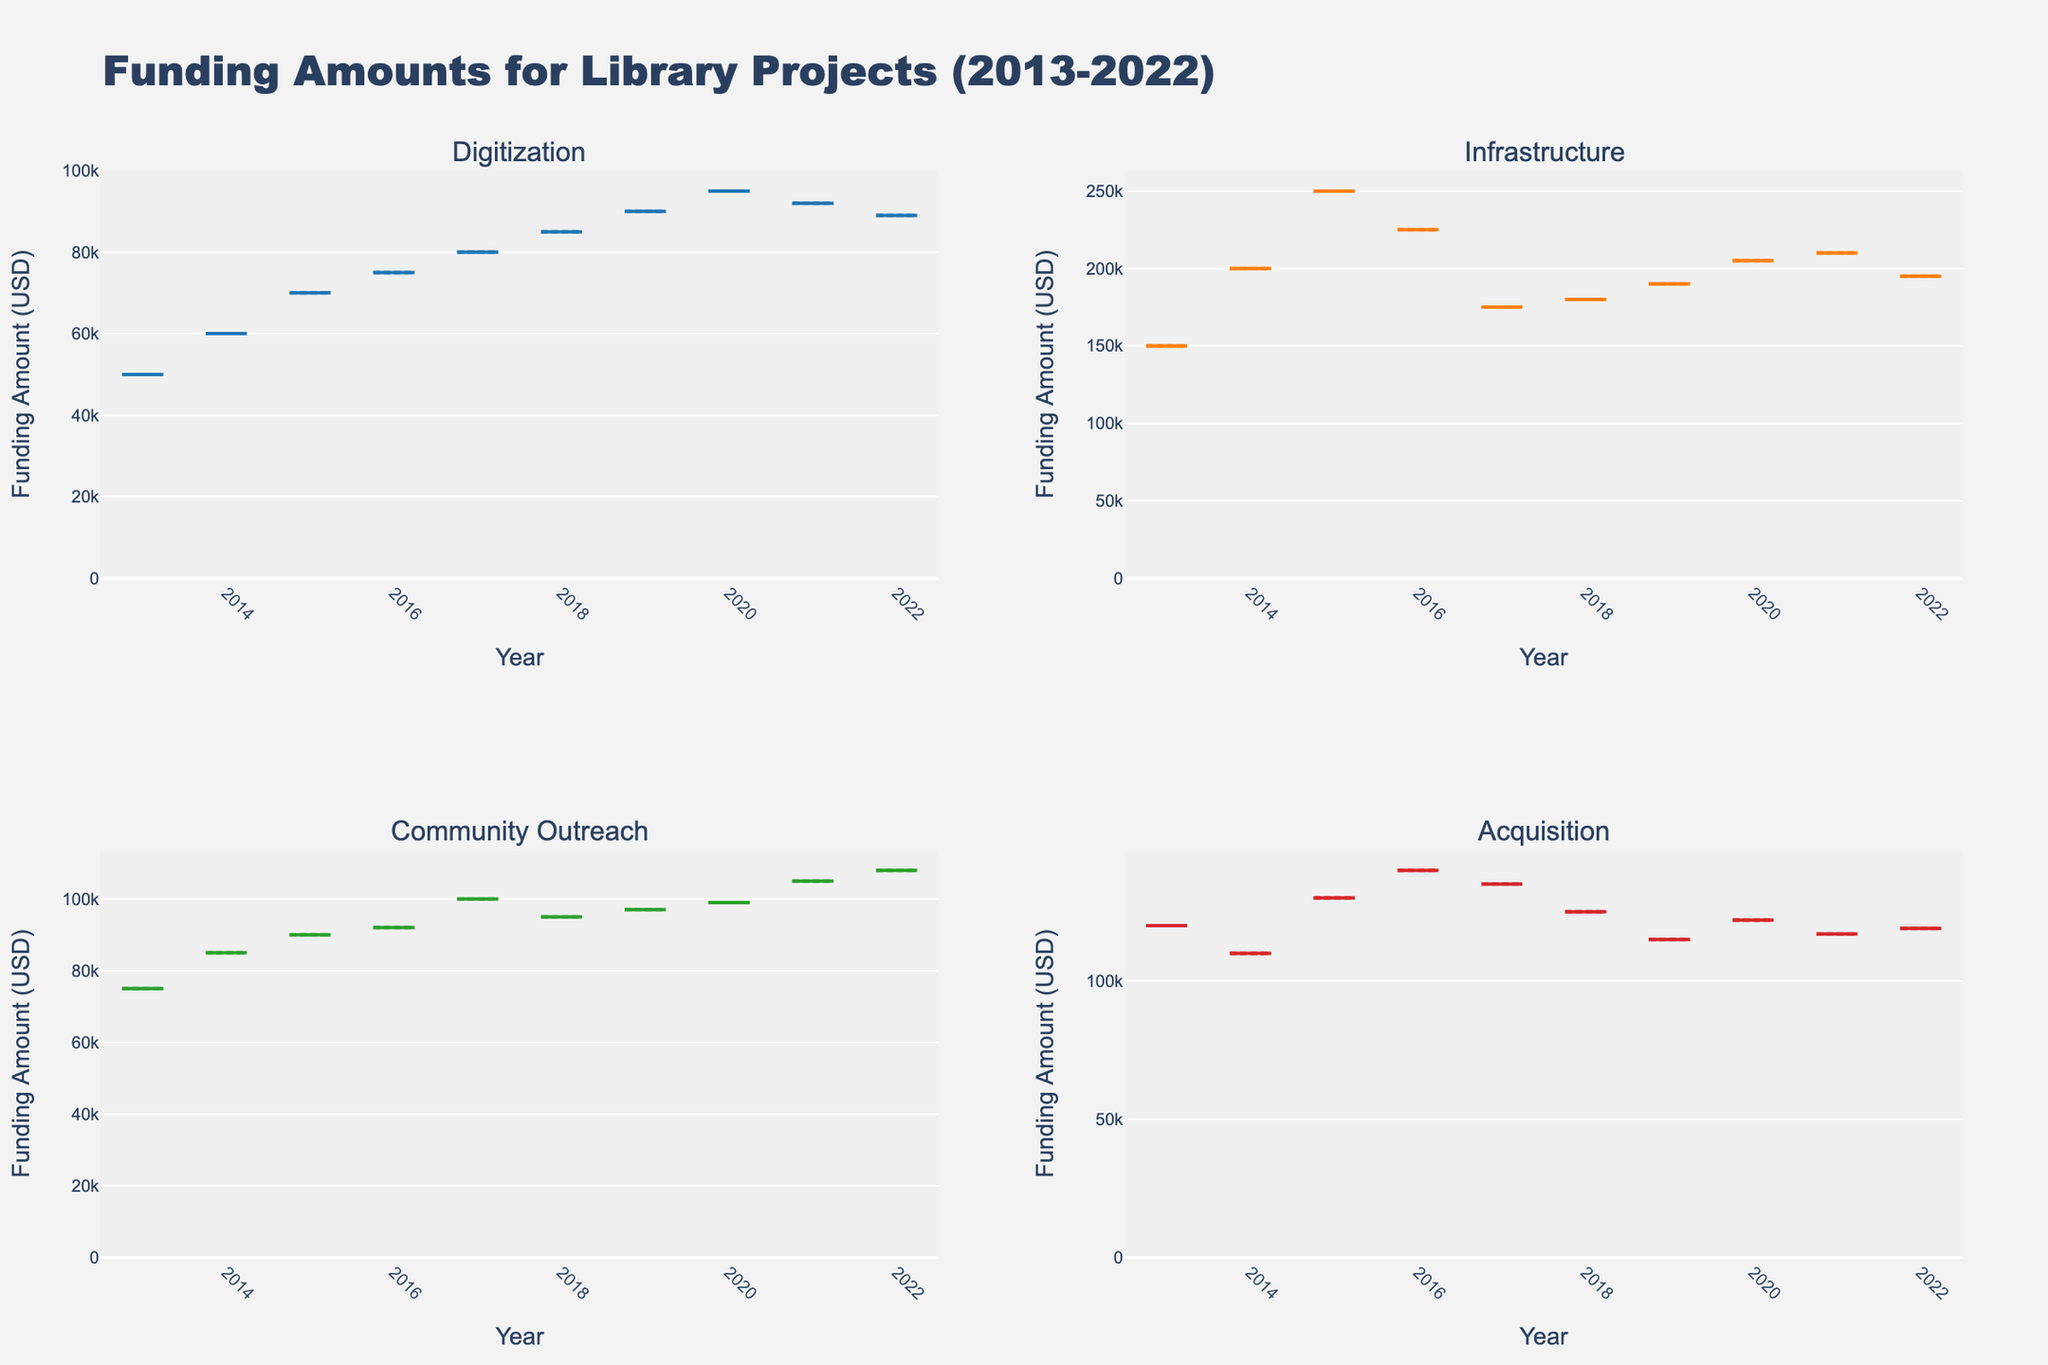What's the title of the figure? The title of the figure is displayed at the top, usually in a larger and bolder font compared to other text elements. It provides a summary or main idea of what the figure represents. In this case, the title is "Funding Amounts for Library Projects (2013-2022)".
Answer: Funding Amounts for Library Projects (2013-2022) How many subplots are there? The figure is divided into multiple panels or sections, each representing a different subset of the data. Typically, these subplots are arranged in a grid layout. In this figure, there are four subplots, each representing a different project type.
Answer: 4 Which project type has the highest median funding amount in 2020? To find the answer, look at the position of the median line within the 2020 box in each subplot. The subplot with the highest median line represents the highest median funding amount. The highest median in 2020 is in the "Infrastructure" project type.
Answer: Infrastructure Which project type shows the most consistent funding amount over the years? Consistency is indicated by the spread of the box plots, where a smaller spread (smaller boxes and whiskers) shows more consistency. In this figure, the "Digitization" project type has the smallest spread, indicating the most consistent funding amount.
Answer: Digitization What is the range of the funding amount for Community Outreach projects in 2022? The range is determined by the minimum and maximum values shown by the whiskers and outliers of the box plot for Community Outreach in 2022. The box plot shows that the funding range is between $105,000 and $108,000.
Answer: $105,000 - $108,000 Which year had the highest average funding for Digitization projects? To find the year with the highest average funding, look for the year where the mean marker (often represented by a dot or line) is at its highest position within the "Digitization" subplot. The highest mean is in the year 2020.
Answer: 2020 Is the funding amount for Acquisition projects more variable in the first half (2013-2017) or second half (2018-2022) of the decade? To determine variability, compare the spread of the boxes and whiskers in the Acquisition subplot for both halves of the decade. The boxes and whiskers are larger (more spread out) in the second half, indicating more variability.
Answer: Second half How did the median funding amount for Infrastructure projects change from 2013 to 2022? Look at the position of the median line in the 2013 and 2022 box plots within the "Infrastructure" subplot. There is an increase in the median funding amount from 2013 ($150,000) to 2022 ($195,000).
Answer: Increased Which project type received the highest funding in any given year across the entire decade? Observe each year in each subplot for the maximum outlier or the highest whisker. The highest funding amount can be seen in "Infrastructure" in 2015, reaching $250,000.
Answer: Infrastructure For Community Outreach projects, did the median funding amount in 2022 surpass the median funding amount in 2013? Compare the median lines (the central line in the box) within the Community Outreach subplot for the years 2013 and 2022. The median funding in 2022 is higher than in 2013.
Answer: Yes 